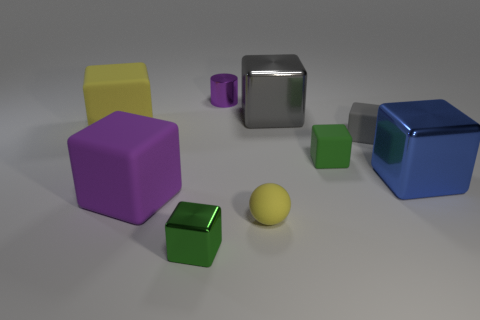How many things are either tiny green objects that are behind the small yellow matte object or things that are in front of the gray shiny block?
Provide a short and direct response. 7. How many yellow shiny objects are the same shape as the gray metal thing?
Your answer should be very brief. 0. There is a thing that is in front of the purple matte thing and to the left of the small purple metallic object; what is its material?
Your response must be concise. Metal. There is a tiny yellow thing; how many green metal objects are behind it?
Offer a very short reply. 0. What number of yellow spheres are there?
Your answer should be very brief. 1. Do the rubber ball and the blue block have the same size?
Offer a terse response. No. Is there a tiny gray rubber cube to the right of the tiny green thing right of the tiny metal thing that is behind the large yellow thing?
Provide a succinct answer. Yes. There is a yellow thing that is the same shape as the big gray metallic thing; what is it made of?
Make the answer very short. Rubber. There is a small shiny object behind the small ball; what color is it?
Your answer should be very brief. Purple. The blue cube is what size?
Your answer should be very brief. Large. 